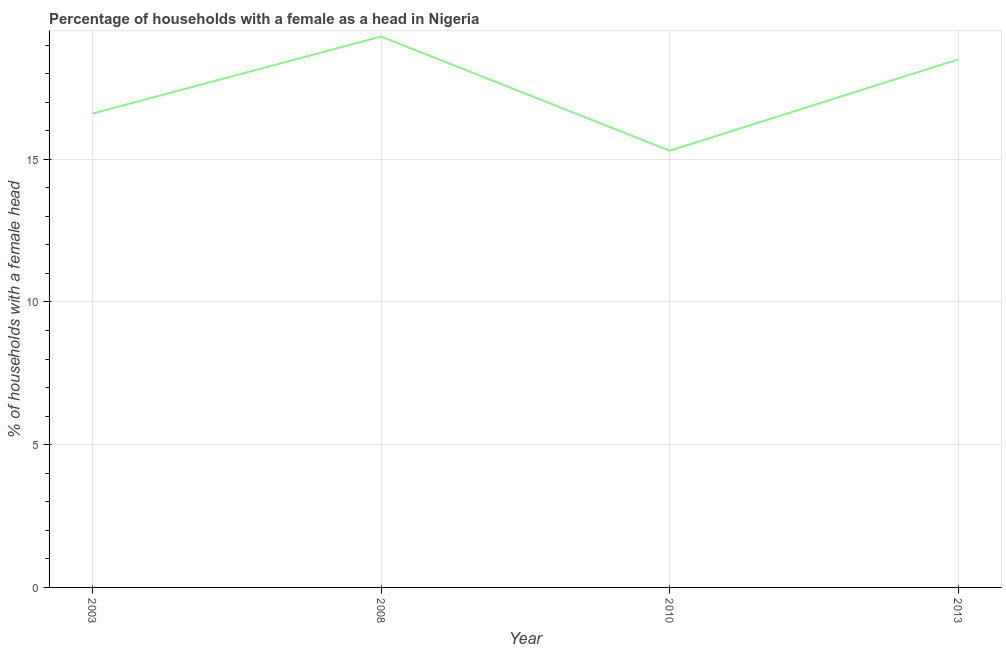Across all years, what is the maximum number of female supervised households?
Ensure brevity in your answer.  19.3. In which year was the number of female supervised households maximum?
Offer a very short reply. 2008. What is the sum of the number of female supervised households?
Your answer should be very brief. 69.7. What is the difference between the number of female supervised households in 2008 and 2010?
Your answer should be compact. 4. What is the average number of female supervised households per year?
Your answer should be very brief. 17.43. What is the median number of female supervised households?
Offer a terse response. 17.55. In how many years, is the number of female supervised households greater than 1 %?
Provide a succinct answer. 4. What is the ratio of the number of female supervised households in 2008 to that in 2013?
Your answer should be compact. 1.04. What is the difference between the highest and the second highest number of female supervised households?
Offer a terse response. 0.8. Is the sum of the number of female supervised households in 2008 and 2013 greater than the maximum number of female supervised households across all years?
Offer a terse response. Yes. In how many years, is the number of female supervised households greater than the average number of female supervised households taken over all years?
Your answer should be compact. 2. Does the number of female supervised households monotonically increase over the years?
Provide a short and direct response. No. How many lines are there?
Provide a short and direct response. 1. What is the difference between two consecutive major ticks on the Y-axis?
Offer a very short reply. 5. What is the title of the graph?
Offer a terse response. Percentage of households with a female as a head in Nigeria. What is the label or title of the Y-axis?
Provide a succinct answer. % of households with a female head. What is the % of households with a female head of 2003?
Provide a succinct answer. 16.6. What is the % of households with a female head of 2008?
Provide a short and direct response. 19.3. What is the % of households with a female head of 2013?
Your response must be concise. 18.5. What is the difference between the % of households with a female head in 2003 and 2010?
Ensure brevity in your answer.  1.3. What is the difference between the % of households with a female head in 2003 and 2013?
Make the answer very short. -1.9. What is the difference between the % of households with a female head in 2010 and 2013?
Give a very brief answer. -3.2. What is the ratio of the % of households with a female head in 2003 to that in 2008?
Ensure brevity in your answer.  0.86. What is the ratio of the % of households with a female head in 2003 to that in 2010?
Your response must be concise. 1.08. What is the ratio of the % of households with a female head in 2003 to that in 2013?
Make the answer very short. 0.9. What is the ratio of the % of households with a female head in 2008 to that in 2010?
Make the answer very short. 1.26. What is the ratio of the % of households with a female head in 2008 to that in 2013?
Provide a succinct answer. 1.04. What is the ratio of the % of households with a female head in 2010 to that in 2013?
Give a very brief answer. 0.83. 